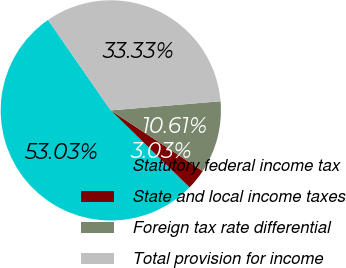Convert chart to OTSL. <chart><loc_0><loc_0><loc_500><loc_500><pie_chart><fcel>Statutory federal income tax<fcel>State and local income taxes<fcel>Foreign tax rate differential<fcel>Total provision for income<nl><fcel>53.03%<fcel>3.03%<fcel>10.61%<fcel>33.33%<nl></chart> 